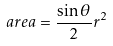Convert formula to latex. <formula><loc_0><loc_0><loc_500><loc_500>a r e a = \frac { \sin \theta } { 2 } r ^ { 2 }</formula> 